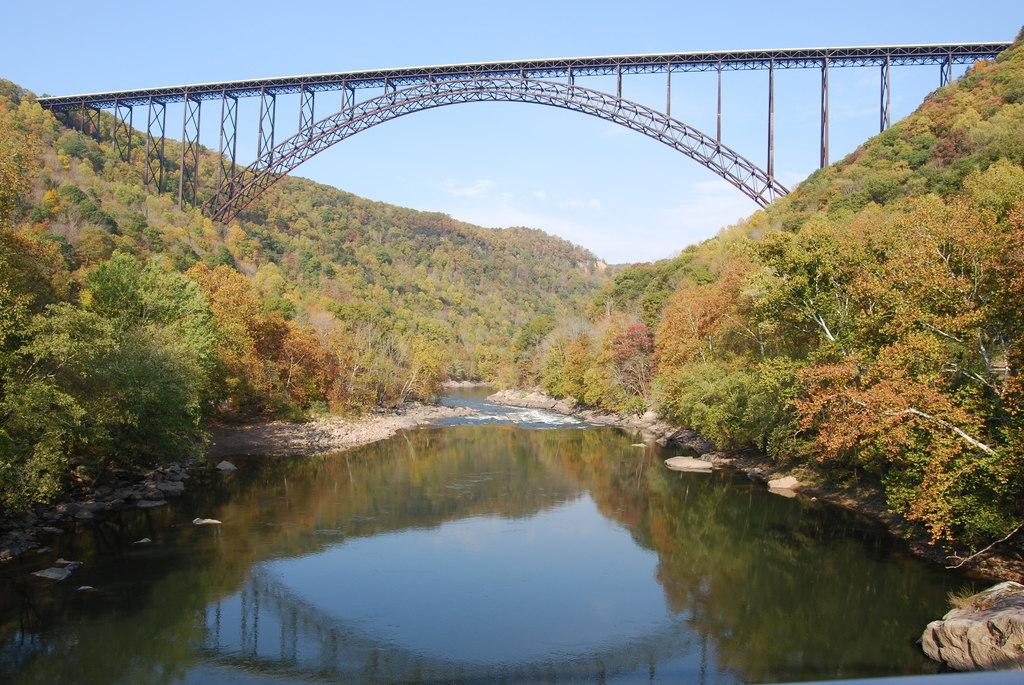What type of structure can be seen in the image? There is a bridge in the image. What type of natural environment is visible in the image? There are trees, hills, water, and rocks visible in the image. What is visible in the sky in the image? The sky is visible in the image, and there are clouds present. What type of letter is being delivered by the society in the image? There is no reference to a letter or society in the image. 